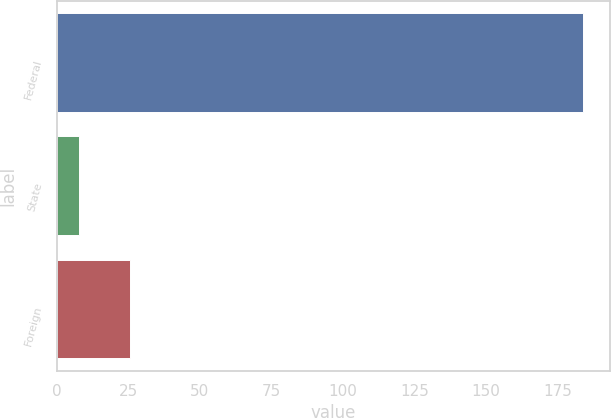<chart> <loc_0><loc_0><loc_500><loc_500><bar_chart><fcel>Federal<fcel>State<fcel>Foreign<nl><fcel>184.1<fcel>7.9<fcel>25.52<nl></chart> 